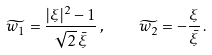Convert formula to latex. <formula><loc_0><loc_0><loc_500><loc_500>\widetilde { w _ { 1 } } = \frac { | \xi | ^ { 2 } - 1 } { \sqrt { 2 } \, \bar { \xi } } \, , \quad \widetilde { w _ { 2 } } = - \frac { \xi } { \bar { \xi } } \, .</formula> 